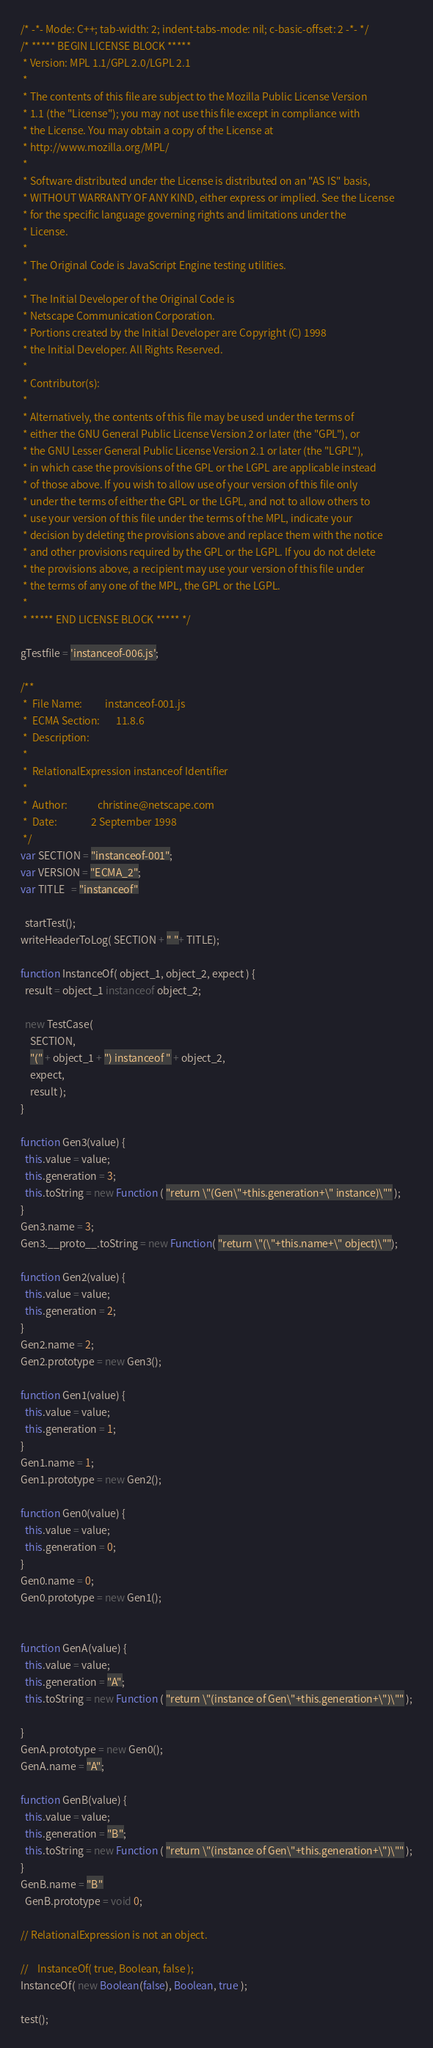Convert code to text. <code><loc_0><loc_0><loc_500><loc_500><_JavaScript_>/* -*- Mode: C++; tab-width: 2; indent-tabs-mode: nil; c-basic-offset: 2 -*- */
/* ***** BEGIN LICENSE BLOCK *****
 * Version: MPL 1.1/GPL 2.0/LGPL 2.1
 *
 * The contents of this file are subject to the Mozilla Public License Version
 * 1.1 (the "License"); you may not use this file except in compliance with
 * the License. You may obtain a copy of the License at
 * http://www.mozilla.org/MPL/
 *
 * Software distributed under the License is distributed on an "AS IS" basis,
 * WITHOUT WARRANTY OF ANY KIND, either express or implied. See the License
 * for the specific language governing rights and limitations under the
 * License.
 *
 * The Original Code is JavaScript Engine testing utilities.
 *
 * The Initial Developer of the Original Code is
 * Netscape Communication Corporation.
 * Portions created by the Initial Developer are Copyright (C) 1998
 * the Initial Developer. All Rights Reserved.
 *
 * Contributor(s):
 *
 * Alternatively, the contents of this file may be used under the terms of
 * either the GNU General Public License Version 2 or later (the "GPL"), or
 * the GNU Lesser General Public License Version 2.1 or later (the "LGPL"),
 * in which case the provisions of the GPL or the LGPL are applicable instead
 * of those above. If you wish to allow use of your version of this file only
 * under the terms of either the GPL or the LGPL, and not to allow others to
 * use your version of this file under the terms of the MPL, indicate your
 * decision by deleting the provisions above and replace them with the notice
 * and other provisions required by the GPL or the LGPL. If you do not delete
 * the provisions above, a recipient may use your version of this file under
 * the terms of any one of the MPL, the GPL or the LGPL.
 *
 * ***** END LICENSE BLOCK ***** */

gTestfile = 'instanceof-006.js';

/**
 *  File Name:          instanceof-001.js
 *  ECMA Section:       11.8.6
 *  Description:
 *
 *  RelationalExpression instanceof Identifier
 *
 *  Author:             christine@netscape.com
 *  Date:               2 September 1998
 */
var SECTION = "instanceof-001";
var VERSION = "ECMA_2";
var TITLE   = "instanceof"

  startTest();
writeHeaderToLog( SECTION + " "+ TITLE);

function InstanceOf( object_1, object_2, expect ) {
  result = object_1 instanceof object_2;

  new TestCase(
    SECTION,
    "(" + object_1 + ") instanceof " + object_2,
    expect,
    result );
}

function Gen3(value) {
  this.value = value;
  this.generation = 3;
  this.toString = new Function ( "return \"(Gen\"+this.generation+\" instance)\"" );
}
Gen3.name = 3;
Gen3.__proto__.toString = new Function( "return \"(\"+this.name+\" object)\"");

function Gen2(value) {
  this.value = value;
  this.generation = 2;
}
Gen2.name = 2;
Gen2.prototype = new Gen3();

function Gen1(value) {
  this.value = value;
  this.generation = 1;
}
Gen1.name = 1;
Gen1.prototype = new Gen2();

function Gen0(value) {
  this.value = value;
  this.generation = 0;
}
Gen0.name = 0;
Gen0.prototype = new Gen1();


function GenA(value) {
  this.value = value;
  this.generation = "A";
  this.toString = new Function ( "return \"(instance of Gen\"+this.generation+\")\"" );

}
GenA.prototype = new Gen0();
GenA.name = "A";

function GenB(value) {
  this.value = value;
  this.generation = "B";
  this.toString = new Function ( "return \"(instance of Gen\"+this.generation+\")\"" );
}
GenB.name = "B"
  GenB.prototype = void 0;

// RelationalExpression is not an object.

//    InstanceOf( true, Boolean, false );
InstanceOf( new Boolean(false), Boolean, true );

test();
</code> 